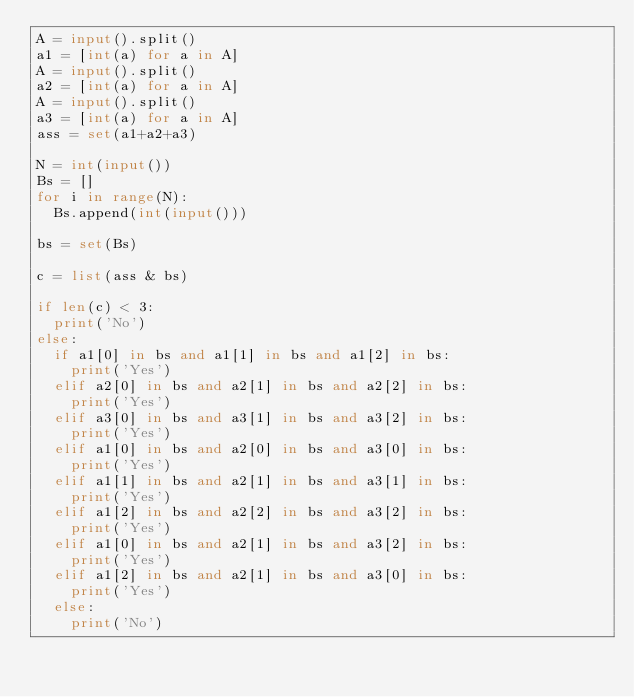Convert code to text. <code><loc_0><loc_0><loc_500><loc_500><_Python_>A = input().split()
a1 = [int(a) for a in A]
A = input().split()
a2 = [int(a) for a in A]
A = input().split()
a3 = [int(a) for a in A]
ass = set(a1+a2+a3)

N = int(input())
Bs = []
for i in range(N):
  Bs.append(int(input()))

bs = set(Bs)

c = list(ass & bs)

if len(c) < 3:
  print('No')
else:
  if a1[0] in bs and a1[1] in bs and a1[2] in bs:
    print('Yes')
  elif a2[0] in bs and a2[1] in bs and a2[2] in bs:
    print('Yes')
  elif a3[0] in bs and a3[1] in bs and a3[2] in bs:
    print('Yes')
  elif a1[0] in bs and a2[0] in bs and a3[0] in bs:
    print('Yes')
  elif a1[1] in bs and a2[1] in bs and a3[1] in bs:
    print('Yes')
  elif a1[2] in bs and a2[2] in bs and a3[2] in bs:
    print('Yes')
  elif a1[0] in bs and a2[1] in bs and a3[2] in bs:
    print('Yes')
  elif a1[2] in bs and a2[1] in bs and a3[0] in bs:
    print('Yes')
  else:
    print('No')
</code> 